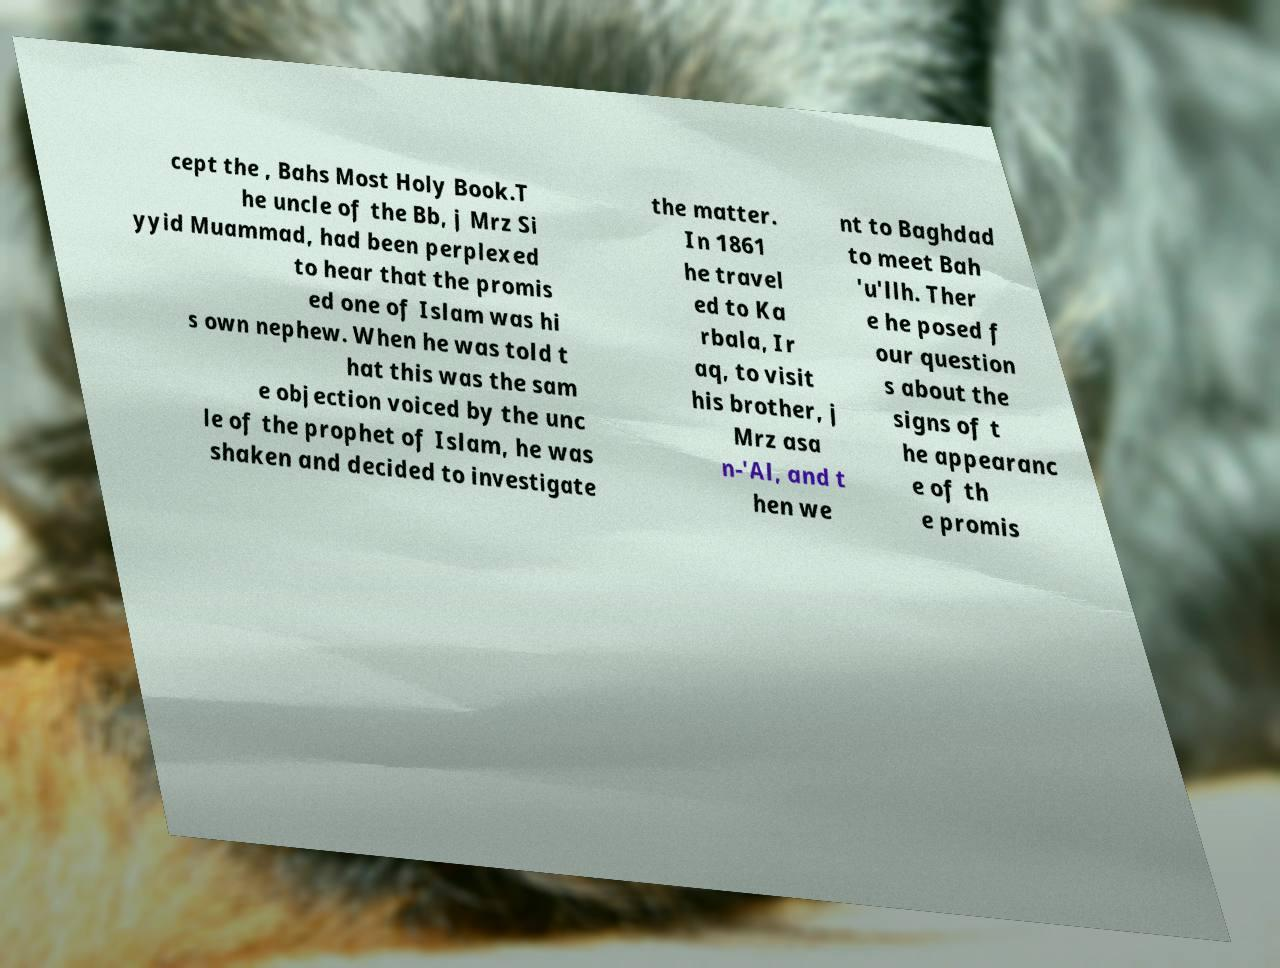There's text embedded in this image that I need extracted. Can you transcribe it verbatim? cept the , Bahs Most Holy Book.T he uncle of the Bb, j Mrz Si yyid Muammad, had been perplexed to hear that the promis ed one of Islam was hi s own nephew. When he was told t hat this was the sam e objection voiced by the unc le of the prophet of Islam, he was shaken and decided to investigate the matter. In 1861 he travel ed to Ka rbala, Ir aq, to visit his brother, j Mrz asa n-'Al, and t hen we nt to Baghdad to meet Bah 'u'llh. Ther e he posed f our question s about the signs of t he appearanc e of th e promis 